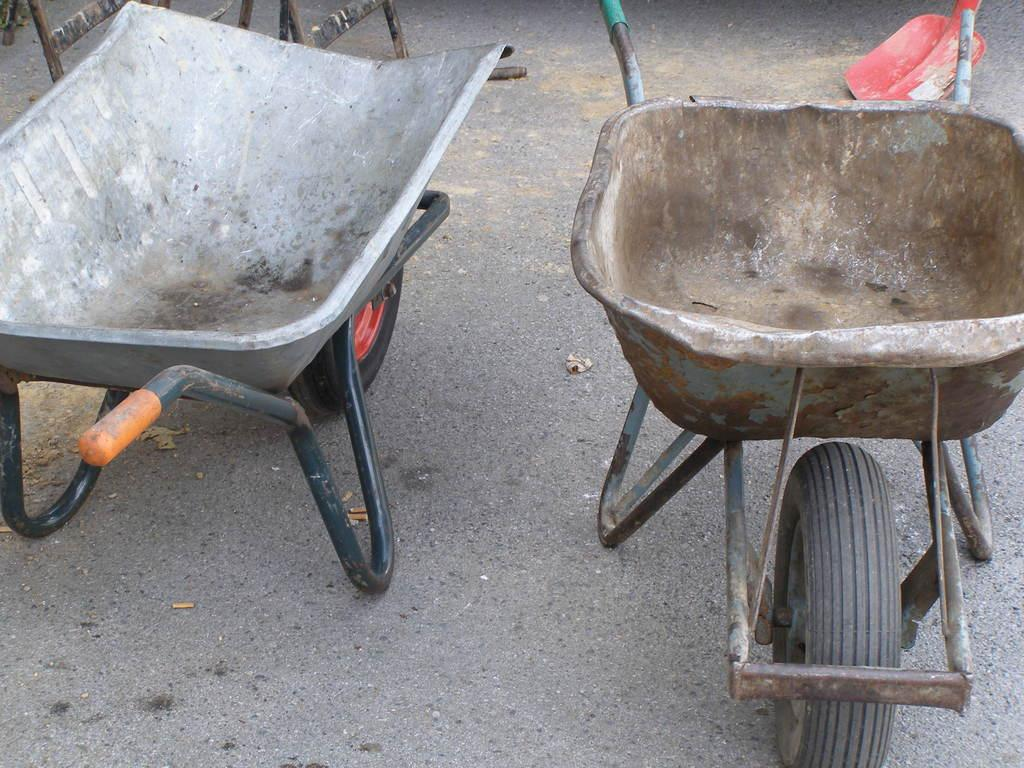How many wheelbarrows are visible in the image? There are two wheelbarrows in the image. Where are the wheelbarrows located? The wheelbarrows are on the road. What type of order is being delivered by the wheelbarrows in the image? There is no indication of an order being delivered in the image; it simply shows two wheelbarrows on the road. 